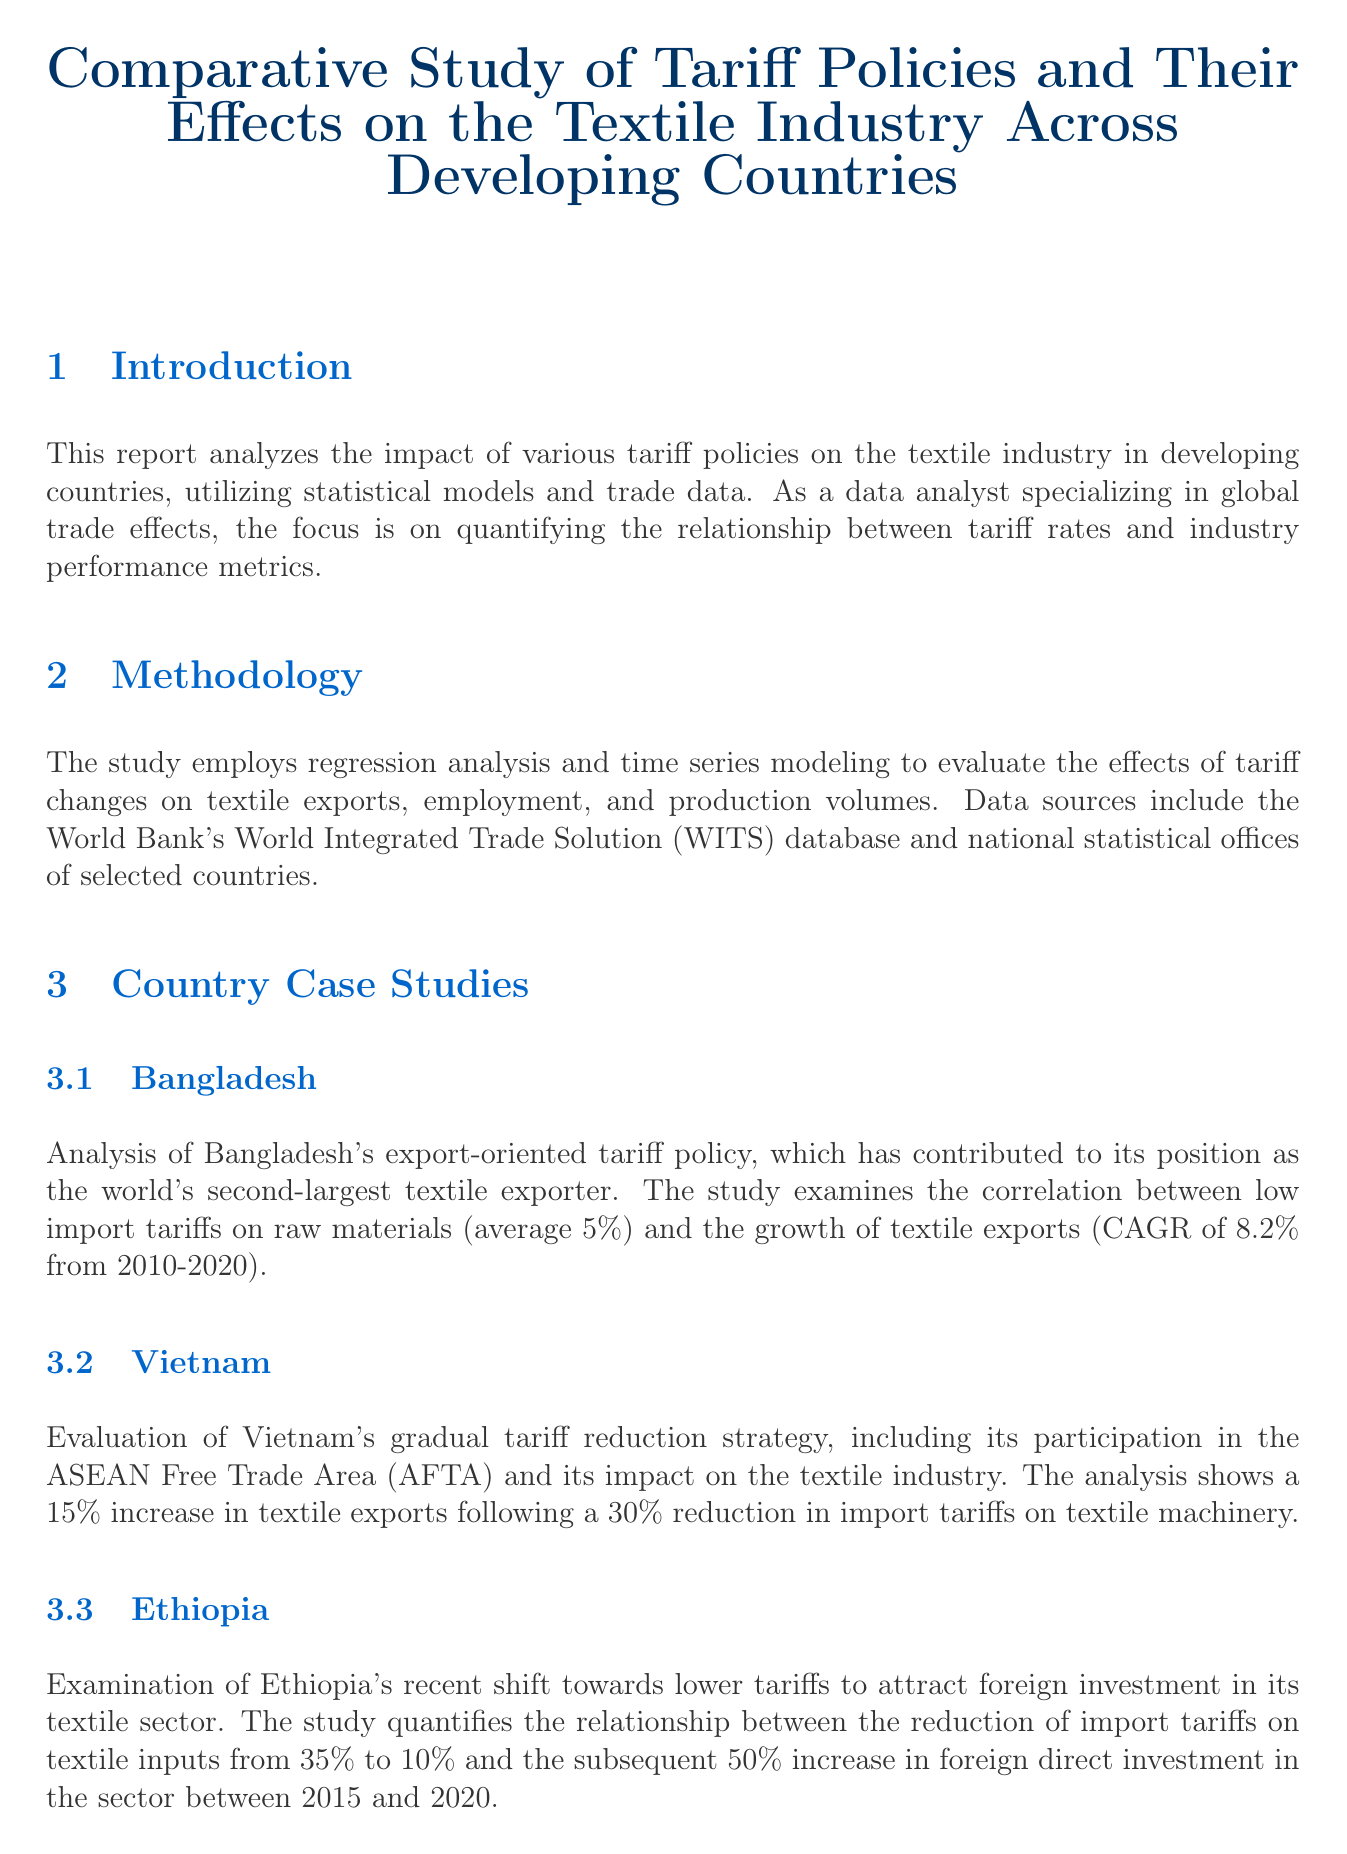What is the title of the report? The title of the report is stated at the beginning, summarizing its focus on tariff policies and the textile industry in developing countries.
Answer: Comparative Study of Tariff Policies and Their Effects on the Textile Industry Across Developing Countries What statistical tools are mentioned in the report? The report lists various statistical tools used for data analysis, including R, Python, STATA, and Gephi.
Answer: R, Python, STATA, Gephi What is the CAGR of textile exports in Bangladesh? The report mentions that the Compound Annual Growth Rate (CAGR) of textile exports in Bangladesh is calculated from 2010 to 2020.
Answer: 8.2% What was the reduction in import tariffs on textile machinery in Vietnam? The report provides information on a specific percentage reduction in tariffs on textile machinery that led to an increase in exports.
Answer: 30% What is the increase in foreign direct investment in Ethiopia's textile sector? The document discusses the effect of reduced tariffs on foreign direct investment, indicating a substantial percentage increase.
Answer: 50% What average employment growth was experienced in countries with liberalized tariff policies? The study compares employment growth between liberalized and protectionist policies, revealing an average growth figure.
Answer: 12% Which country is the world’s second-largest textile exporter? The report identifies a specific country known for its export-oriented tariff policy in textiles.
Answer: Bangladesh What does the comparative analysis reveal about tariff reductions? The report highlights a key finding regarding the relationship between tariff reductions and export volume growth across countries.
Answer: 7.5% 